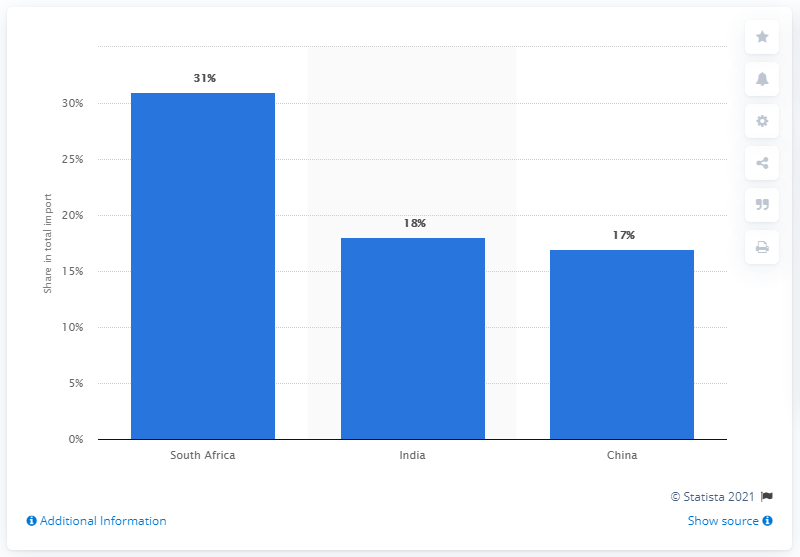Point out several critical features in this image. In 2019, Mozambique's most important import partner was South Africa. In 2019, South Africa was the most significant import partner for Mozambique, accounting for 31% of the country's total imports. 